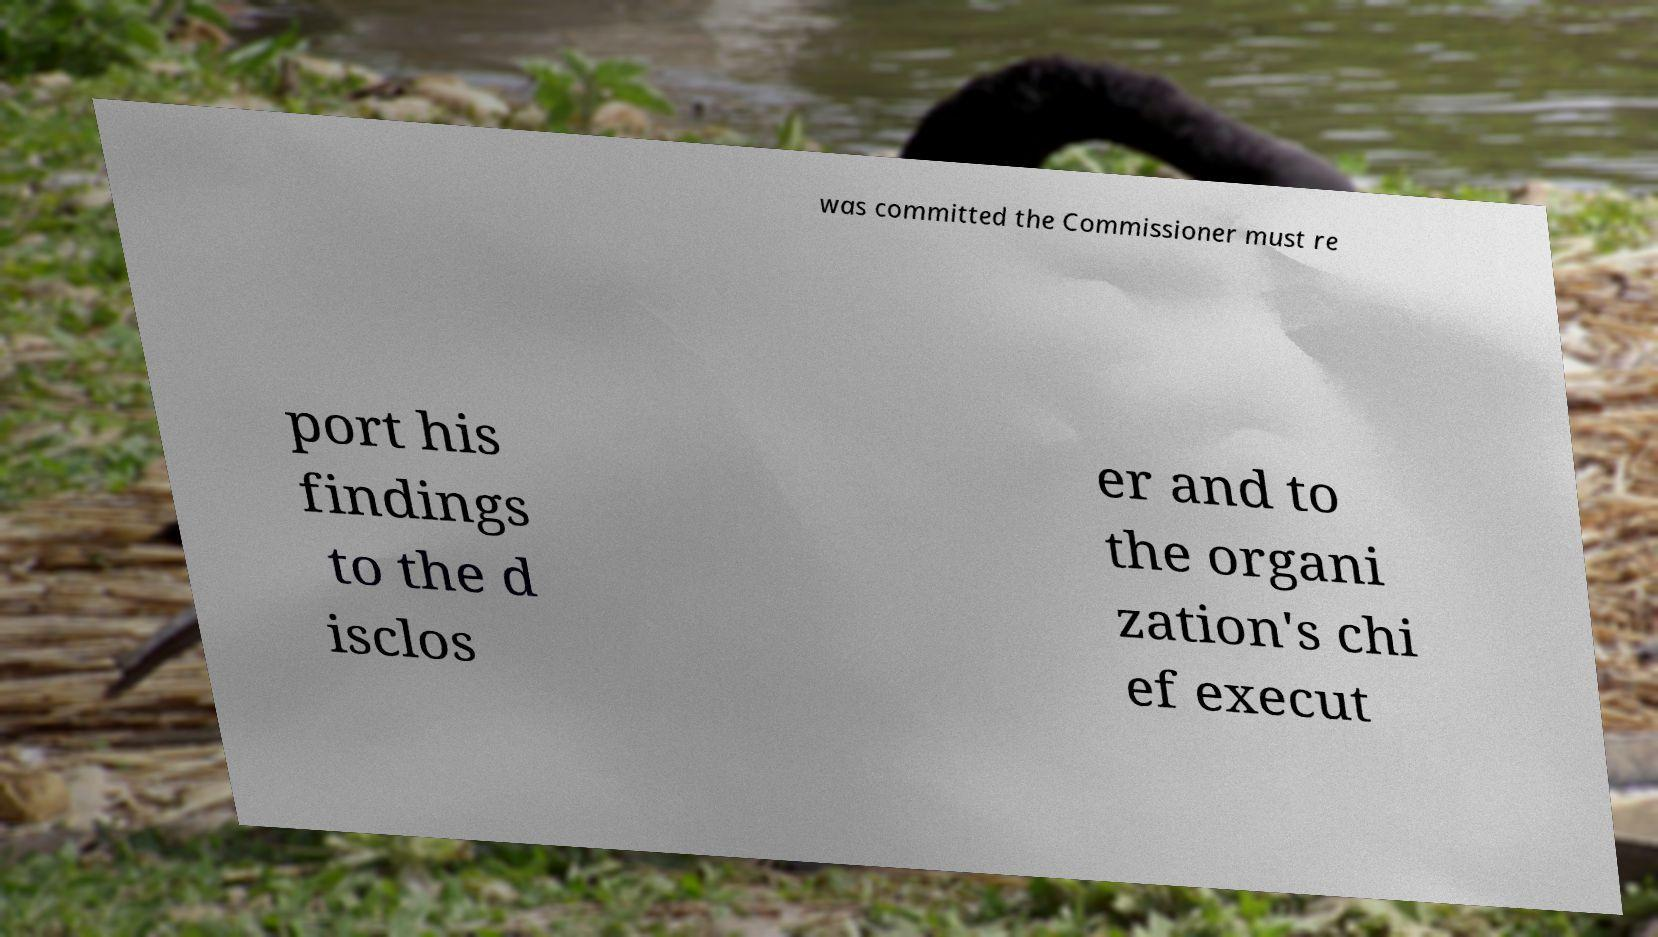I need the written content from this picture converted into text. Can you do that? was committed the Commissioner must re port his findings to the d isclos er and to the organi zation's chi ef execut 